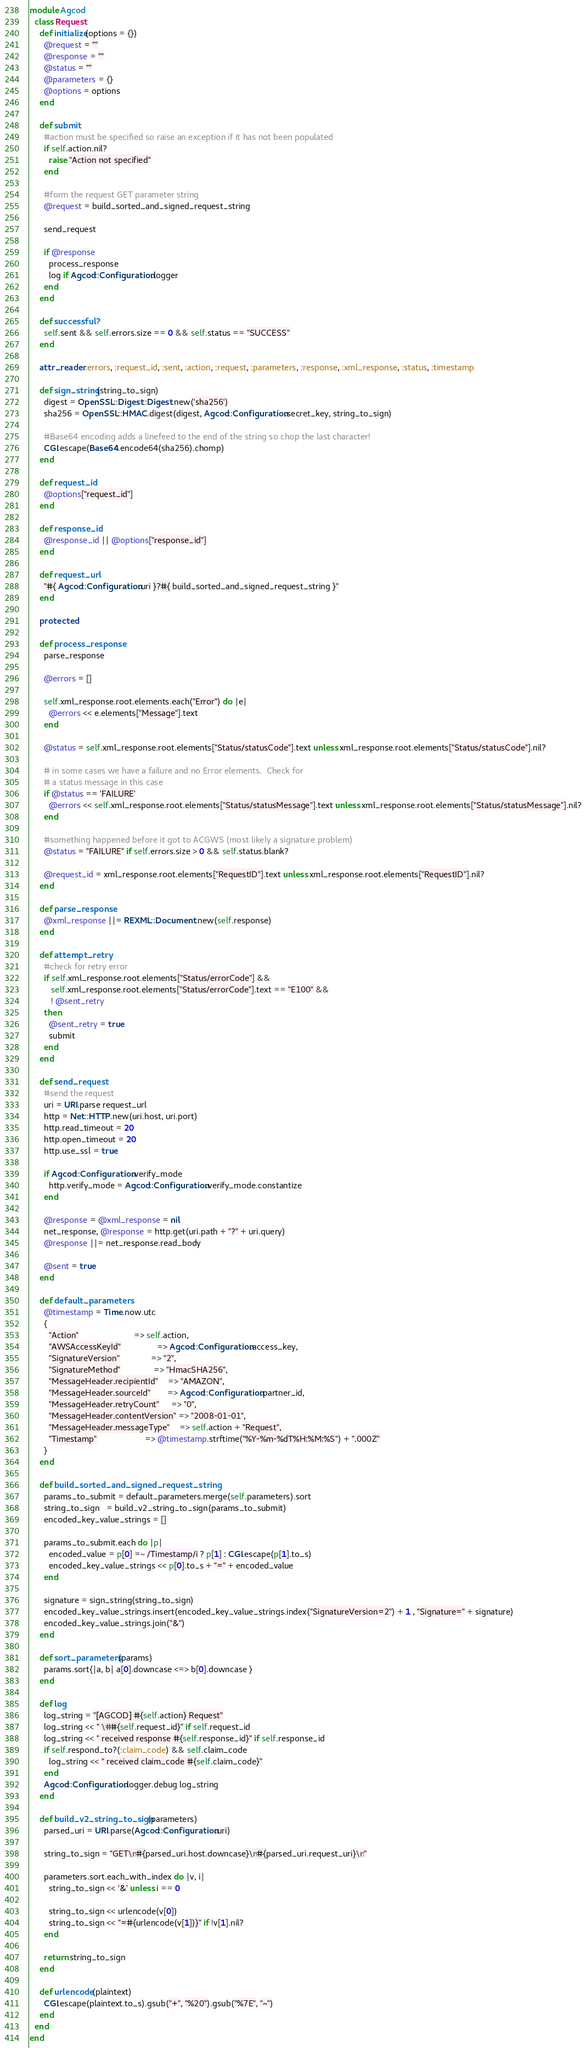Convert code to text. <code><loc_0><loc_0><loc_500><loc_500><_Ruby_>module Agcod
  class Request
    def initialize(options = {})
      @request = ""
      @response = ""
      @status = ""
      @parameters = {}
      @options = options
    end

    def submit
      #action must be specified so raise an exception if it has not been populated
      if self.action.nil?
        raise "Action not specified"
      end

      #form the request GET parameter string
      @request = build_sorted_and_signed_request_string

      send_request

      if @response
        process_response
        log if Agcod::Configuration.logger
      end
    end

    def successful?
      self.sent && self.errors.size == 0 && self.status == "SUCCESS"
    end

    attr_reader :errors, :request_id, :sent, :action, :request, :parameters, :response, :xml_response, :status, :timestamp

    def sign_string(string_to_sign)
      digest = OpenSSL::Digest::Digest.new('sha256')
      sha256 = OpenSSL::HMAC.digest(digest, Agcod::Configuration.secret_key, string_to_sign)

      #Base64 encoding adds a linefeed to the end of the string so chop the last character!
      CGI.escape(Base64.encode64(sha256).chomp)
    end

    def request_id
      @options["request_id"]
    end

    def response_id
      @response_id || @options["response_id"]
    end

    def request_url
      "#{ Agcod::Configuration.uri }?#{ build_sorted_and_signed_request_string }"
    end

    protected

    def process_response
      parse_response

      @errors = []

      self.xml_response.root.elements.each("Error") do |e|
        @errors << e.elements["Message"].text
      end

      @status = self.xml_response.root.elements["Status/statusCode"].text unless xml_response.root.elements["Status/statusCode"].nil?

      # in some cases we have a failure and no Error elements.  Check for
      # a status message in this case
      if @status == 'FAILURE'
        @errors << self.xml_response.root.elements["Status/statusMessage"].text unless xml_response.root.elements["Status/statusMessage"].nil?
      end

      #something happened before it got to ACGWS (most likely a signature problem)
      @status = "FAILURE" if self.errors.size > 0 && self.status.blank?

      @request_id = xml_response.root.elements["RequestID"].text unless xml_response.root.elements["RequestID"].nil?
    end

    def parse_response
      @xml_response ||= REXML::Document.new(self.response)
    end

    def attempt_retry
      #check for retry error
      if self.xml_response.root.elements["Status/errorCode"] &&
         self.xml_response.root.elements["Status/errorCode"].text == "E100" &&
         ! @sent_retry
      then
        @sent_retry = true
        submit
      end
    end

    def send_request
      #send the request
      uri = URI.parse request_url
      http = Net::HTTP.new(uri.host, uri.port)
      http.read_timeout = 20
      http.open_timeout = 20
      http.use_ssl = true

      if Agcod::Configuration.verify_mode
        http.verify_mode = Agcod::Configuration.verify_mode.constantize
      end

      @response = @xml_response = nil
      net_response, @response = http.get(uri.path + "?" + uri.query)
      @response ||= net_response.read_body

      @sent = true
    end

    def default_parameters
      @timestamp = Time.now.utc
      {
        "Action"                       => self.action,
        "AWSAccessKeyId"               => Agcod::Configuration.access_key,
        "SignatureVersion"             => "2",
        "SignatureMethod"              => "HmacSHA256",
        "MessageHeader.recipientId"    => "AMAZON",
        "MessageHeader.sourceId"       => Agcod::Configuration.partner_id,
        "MessageHeader.retryCount"     => "0",
        "MessageHeader.contentVersion" => "2008-01-01",
        "MessageHeader.messageType"    => self.action + "Request",
        "Timestamp"                    => @timestamp.strftime("%Y-%m-%dT%H:%M:%S") + ".000Z"
      }
    end

    def build_sorted_and_signed_request_string
      params_to_submit = default_parameters.merge(self.parameters).sort
      string_to_sign   = build_v2_string_to_sign(params_to_submit)
      encoded_key_value_strings = []

      params_to_submit.each do |p|
        encoded_value = p[0] =~ /Timestamp/i ? p[1] : CGI.escape(p[1].to_s)
        encoded_key_value_strings << p[0].to_s + "=" + encoded_value
      end

      signature = sign_string(string_to_sign)
      encoded_key_value_strings.insert(encoded_key_value_strings.index("SignatureVersion=2") + 1 , "Signature=" + signature)
      encoded_key_value_strings.join("&")
    end

    def sort_parameters(params)
      params.sort{|a, b| a[0].downcase <=> b[0].downcase }
    end

    def log
      log_string = "[AGCOD] #{self.action} Request"
      log_string << " \##{self.request_id}" if self.request_id
      log_string << " received response #{self.response_id}" if self.response_id
      if self.respond_to?(:claim_code) && self.claim_code
        log_string << " received claim_code #{self.claim_code}"
      end
      Agcod::Configuration.logger.debug log_string
    end

    def build_v2_string_to_sign(parameters)
      parsed_uri = URI.parse(Agcod::Configuration.uri)

      string_to_sign = "GET\n#{parsed_uri.host.downcase}\n#{parsed_uri.request_uri}\n"

      parameters.sort.each_with_index do |v, i|
        string_to_sign << '&' unless i == 0

        string_to_sign << urlencode(v[0])
        string_to_sign << "=#{urlencode(v[1])}" if !v[1].nil?
      end

      return string_to_sign
    end

    def urlencode(plaintext)
      CGI.escape(plaintext.to_s).gsub("+", "%20").gsub("%7E", "~")
    end
  end
end
</code> 